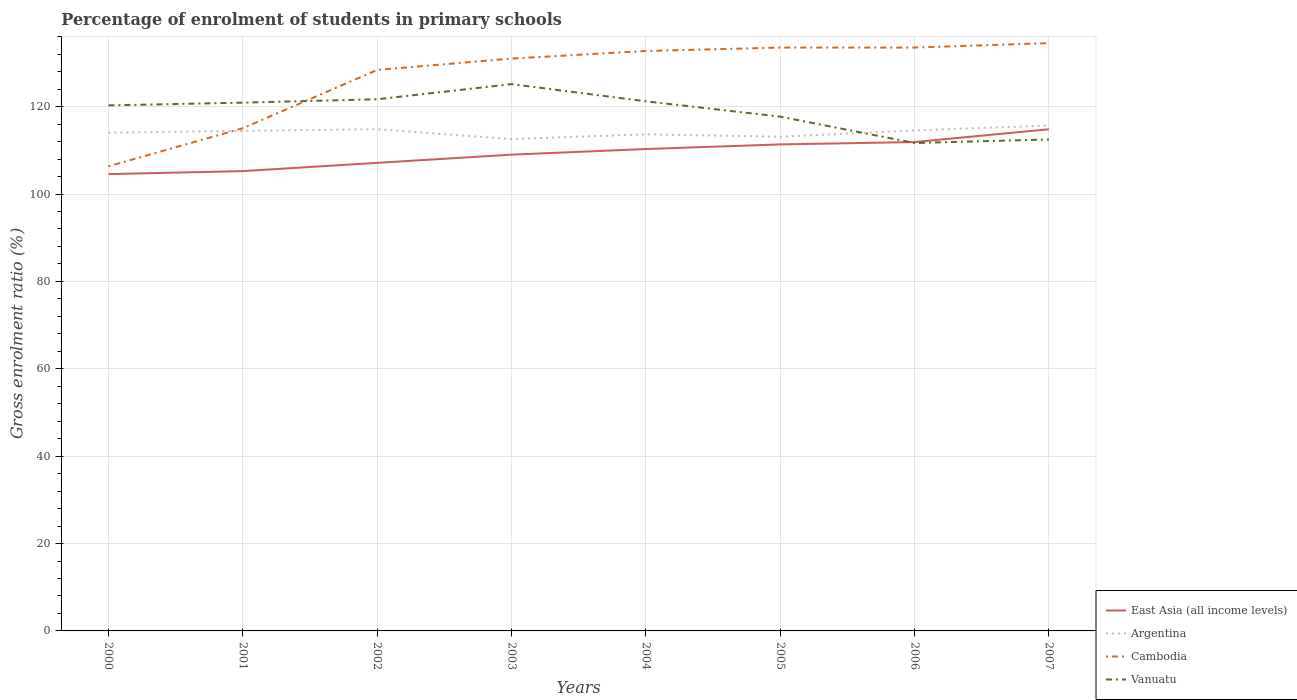Is the number of lines equal to the number of legend labels?
Your answer should be very brief. Yes. Across all years, what is the maximum percentage of students enrolled in primary schools in Cambodia?
Give a very brief answer. 106.34. In which year was the percentage of students enrolled in primary schools in Argentina maximum?
Your answer should be very brief. 2003. What is the total percentage of students enrolled in primary schools in Vanuatu in the graph?
Make the answer very short. 7.8. What is the difference between the highest and the second highest percentage of students enrolled in primary schools in Cambodia?
Offer a very short reply. 28.19. What is the difference between the highest and the lowest percentage of students enrolled in primary schools in East Asia (all income levels)?
Your response must be concise. 4. Is the percentage of students enrolled in primary schools in Argentina strictly greater than the percentage of students enrolled in primary schools in Cambodia over the years?
Your answer should be very brief. No. How many lines are there?
Give a very brief answer. 4. How many years are there in the graph?
Your answer should be very brief. 8. Does the graph contain any zero values?
Your response must be concise. No. Where does the legend appear in the graph?
Give a very brief answer. Bottom right. How many legend labels are there?
Your response must be concise. 4. How are the legend labels stacked?
Give a very brief answer. Vertical. What is the title of the graph?
Provide a short and direct response. Percentage of enrolment of students in primary schools. What is the label or title of the X-axis?
Keep it short and to the point. Years. What is the label or title of the Y-axis?
Provide a succinct answer. Gross enrolment ratio (%). What is the Gross enrolment ratio (%) in East Asia (all income levels) in 2000?
Offer a terse response. 104.55. What is the Gross enrolment ratio (%) in Argentina in 2000?
Keep it short and to the point. 114.03. What is the Gross enrolment ratio (%) of Cambodia in 2000?
Offer a terse response. 106.34. What is the Gross enrolment ratio (%) in Vanuatu in 2000?
Make the answer very short. 120.28. What is the Gross enrolment ratio (%) of East Asia (all income levels) in 2001?
Provide a succinct answer. 105.24. What is the Gross enrolment ratio (%) of Argentina in 2001?
Provide a short and direct response. 114.45. What is the Gross enrolment ratio (%) in Cambodia in 2001?
Make the answer very short. 115.05. What is the Gross enrolment ratio (%) of Vanuatu in 2001?
Offer a very short reply. 120.91. What is the Gross enrolment ratio (%) in East Asia (all income levels) in 2002?
Ensure brevity in your answer.  107.13. What is the Gross enrolment ratio (%) of Argentina in 2002?
Offer a terse response. 114.83. What is the Gross enrolment ratio (%) of Cambodia in 2002?
Your response must be concise. 128.4. What is the Gross enrolment ratio (%) in Vanuatu in 2002?
Ensure brevity in your answer.  121.68. What is the Gross enrolment ratio (%) of East Asia (all income levels) in 2003?
Offer a terse response. 109.01. What is the Gross enrolment ratio (%) in Argentina in 2003?
Offer a very short reply. 112.58. What is the Gross enrolment ratio (%) in Cambodia in 2003?
Give a very brief answer. 131. What is the Gross enrolment ratio (%) in Vanuatu in 2003?
Provide a short and direct response. 125.15. What is the Gross enrolment ratio (%) in East Asia (all income levels) in 2004?
Ensure brevity in your answer.  110.29. What is the Gross enrolment ratio (%) in Argentina in 2004?
Provide a succinct answer. 113.66. What is the Gross enrolment ratio (%) of Cambodia in 2004?
Ensure brevity in your answer.  132.73. What is the Gross enrolment ratio (%) in Vanuatu in 2004?
Offer a terse response. 121.22. What is the Gross enrolment ratio (%) of East Asia (all income levels) in 2005?
Your answer should be very brief. 111.35. What is the Gross enrolment ratio (%) in Argentina in 2005?
Provide a short and direct response. 113.11. What is the Gross enrolment ratio (%) of Cambodia in 2005?
Provide a short and direct response. 133.52. What is the Gross enrolment ratio (%) of Vanuatu in 2005?
Provide a short and direct response. 117.71. What is the Gross enrolment ratio (%) of East Asia (all income levels) in 2006?
Ensure brevity in your answer.  111.89. What is the Gross enrolment ratio (%) in Argentina in 2006?
Keep it short and to the point. 114.55. What is the Gross enrolment ratio (%) in Cambodia in 2006?
Offer a very short reply. 133.51. What is the Gross enrolment ratio (%) in Vanuatu in 2006?
Your answer should be compact. 111.67. What is the Gross enrolment ratio (%) in East Asia (all income levels) in 2007?
Provide a succinct answer. 114.82. What is the Gross enrolment ratio (%) in Argentina in 2007?
Make the answer very short. 115.67. What is the Gross enrolment ratio (%) in Cambodia in 2007?
Your answer should be compact. 134.53. What is the Gross enrolment ratio (%) in Vanuatu in 2007?
Give a very brief answer. 112.48. Across all years, what is the maximum Gross enrolment ratio (%) of East Asia (all income levels)?
Your answer should be very brief. 114.82. Across all years, what is the maximum Gross enrolment ratio (%) in Argentina?
Provide a short and direct response. 115.67. Across all years, what is the maximum Gross enrolment ratio (%) in Cambodia?
Your answer should be compact. 134.53. Across all years, what is the maximum Gross enrolment ratio (%) in Vanuatu?
Ensure brevity in your answer.  125.15. Across all years, what is the minimum Gross enrolment ratio (%) in East Asia (all income levels)?
Make the answer very short. 104.55. Across all years, what is the minimum Gross enrolment ratio (%) of Argentina?
Keep it short and to the point. 112.58. Across all years, what is the minimum Gross enrolment ratio (%) in Cambodia?
Your response must be concise. 106.34. Across all years, what is the minimum Gross enrolment ratio (%) in Vanuatu?
Ensure brevity in your answer.  111.67. What is the total Gross enrolment ratio (%) in East Asia (all income levels) in the graph?
Keep it short and to the point. 874.29. What is the total Gross enrolment ratio (%) of Argentina in the graph?
Ensure brevity in your answer.  912.89. What is the total Gross enrolment ratio (%) in Cambodia in the graph?
Keep it short and to the point. 1015.09. What is the total Gross enrolment ratio (%) in Vanuatu in the graph?
Ensure brevity in your answer.  951.1. What is the difference between the Gross enrolment ratio (%) of East Asia (all income levels) in 2000 and that in 2001?
Ensure brevity in your answer.  -0.69. What is the difference between the Gross enrolment ratio (%) of Argentina in 2000 and that in 2001?
Offer a terse response. -0.42. What is the difference between the Gross enrolment ratio (%) of Cambodia in 2000 and that in 2001?
Give a very brief answer. -8.71. What is the difference between the Gross enrolment ratio (%) of Vanuatu in 2000 and that in 2001?
Your answer should be very brief. -0.62. What is the difference between the Gross enrolment ratio (%) of East Asia (all income levels) in 2000 and that in 2002?
Make the answer very short. -2.57. What is the difference between the Gross enrolment ratio (%) of Argentina in 2000 and that in 2002?
Offer a very short reply. -0.8. What is the difference between the Gross enrolment ratio (%) in Cambodia in 2000 and that in 2002?
Your answer should be compact. -22.05. What is the difference between the Gross enrolment ratio (%) of Vanuatu in 2000 and that in 2002?
Your answer should be compact. -1.4. What is the difference between the Gross enrolment ratio (%) in East Asia (all income levels) in 2000 and that in 2003?
Ensure brevity in your answer.  -4.45. What is the difference between the Gross enrolment ratio (%) of Argentina in 2000 and that in 2003?
Give a very brief answer. 1.46. What is the difference between the Gross enrolment ratio (%) in Cambodia in 2000 and that in 2003?
Provide a short and direct response. -24.66. What is the difference between the Gross enrolment ratio (%) of Vanuatu in 2000 and that in 2003?
Offer a very short reply. -4.86. What is the difference between the Gross enrolment ratio (%) in East Asia (all income levels) in 2000 and that in 2004?
Provide a short and direct response. -5.74. What is the difference between the Gross enrolment ratio (%) in Argentina in 2000 and that in 2004?
Ensure brevity in your answer.  0.38. What is the difference between the Gross enrolment ratio (%) of Cambodia in 2000 and that in 2004?
Make the answer very short. -26.39. What is the difference between the Gross enrolment ratio (%) of Vanuatu in 2000 and that in 2004?
Provide a succinct answer. -0.93. What is the difference between the Gross enrolment ratio (%) in East Asia (all income levels) in 2000 and that in 2005?
Your response must be concise. -6.8. What is the difference between the Gross enrolment ratio (%) in Argentina in 2000 and that in 2005?
Your answer should be very brief. 0.92. What is the difference between the Gross enrolment ratio (%) of Cambodia in 2000 and that in 2005?
Your answer should be compact. -27.17. What is the difference between the Gross enrolment ratio (%) of Vanuatu in 2000 and that in 2005?
Your answer should be very brief. 2.58. What is the difference between the Gross enrolment ratio (%) of East Asia (all income levels) in 2000 and that in 2006?
Offer a terse response. -7.34. What is the difference between the Gross enrolment ratio (%) of Argentina in 2000 and that in 2006?
Give a very brief answer. -0.52. What is the difference between the Gross enrolment ratio (%) in Cambodia in 2000 and that in 2006?
Your answer should be compact. -27.17. What is the difference between the Gross enrolment ratio (%) in Vanuatu in 2000 and that in 2006?
Your response must be concise. 8.62. What is the difference between the Gross enrolment ratio (%) in East Asia (all income levels) in 2000 and that in 2007?
Make the answer very short. -10.26. What is the difference between the Gross enrolment ratio (%) in Argentina in 2000 and that in 2007?
Offer a very short reply. -1.64. What is the difference between the Gross enrolment ratio (%) in Cambodia in 2000 and that in 2007?
Provide a short and direct response. -28.19. What is the difference between the Gross enrolment ratio (%) of Vanuatu in 2000 and that in 2007?
Your answer should be very brief. 7.8. What is the difference between the Gross enrolment ratio (%) of East Asia (all income levels) in 2001 and that in 2002?
Provide a short and direct response. -1.89. What is the difference between the Gross enrolment ratio (%) in Argentina in 2001 and that in 2002?
Make the answer very short. -0.38. What is the difference between the Gross enrolment ratio (%) of Cambodia in 2001 and that in 2002?
Provide a succinct answer. -13.34. What is the difference between the Gross enrolment ratio (%) in Vanuatu in 2001 and that in 2002?
Your response must be concise. -0.77. What is the difference between the Gross enrolment ratio (%) in East Asia (all income levels) in 2001 and that in 2003?
Your answer should be compact. -3.77. What is the difference between the Gross enrolment ratio (%) of Argentina in 2001 and that in 2003?
Provide a short and direct response. 1.88. What is the difference between the Gross enrolment ratio (%) of Cambodia in 2001 and that in 2003?
Ensure brevity in your answer.  -15.95. What is the difference between the Gross enrolment ratio (%) in Vanuatu in 2001 and that in 2003?
Your answer should be very brief. -4.24. What is the difference between the Gross enrolment ratio (%) of East Asia (all income levels) in 2001 and that in 2004?
Keep it short and to the point. -5.05. What is the difference between the Gross enrolment ratio (%) in Argentina in 2001 and that in 2004?
Your answer should be compact. 0.79. What is the difference between the Gross enrolment ratio (%) of Cambodia in 2001 and that in 2004?
Give a very brief answer. -17.68. What is the difference between the Gross enrolment ratio (%) of Vanuatu in 2001 and that in 2004?
Your answer should be very brief. -0.31. What is the difference between the Gross enrolment ratio (%) in East Asia (all income levels) in 2001 and that in 2005?
Your answer should be very brief. -6.11. What is the difference between the Gross enrolment ratio (%) in Argentina in 2001 and that in 2005?
Your answer should be compact. 1.34. What is the difference between the Gross enrolment ratio (%) of Cambodia in 2001 and that in 2005?
Offer a terse response. -18.46. What is the difference between the Gross enrolment ratio (%) of Vanuatu in 2001 and that in 2005?
Give a very brief answer. 3.2. What is the difference between the Gross enrolment ratio (%) in East Asia (all income levels) in 2001 and that in 2006?
Give a very brief answer. -6.65. What is the difference between the Gross enrolment ratio (%) in Argentina in 2001 and that in 2006?
Provide a succinct answer. -0.1. What is the difference between the Gross enrolment ratio (%) of Cambodia in 2001 and that in 2006?
Offer a terse response. -18.46. What is the difference between the Gross enrolment ratio (%) of Vanuatu in 2001 and that in 2006?
Keep it short and to the point. 9.24. What is the difference between the Gross enrolment ratio (%) in East Asia (all income levels) in 2001 and that in 2007?
Provide a succinct answer. -9.58. What is the difference between the Gross enrolment ratio (%) of Argentina in 2001 and that in 2007?
Provide a succinct answer. -1.22. What is the difference between the Gross enrolment ratio (%) of Cambodia in 2001 and that in 2007?
Offer a terse response. -19.48. What is the difference between the Gross enrolment ratio (%) of Vanuatu in 2001 and that in 2007?
Keep it short and to the point. 8.43. What is the difference between the Gross enrolment ratio (%) of East Asia (all income levels) in 2002 and that in 2003?
Your answer should be compact. -1.88. What is the difference between the Gross enrolment ratio (%) of Argentina in 2002 and that in 2003?
Offer a very short reply. 2.26. What is the difference between the Gross enrolment ratio (%) in Cambodia in 2002 and that in 2003?
Ensure brevity in your answer.  -2.6. What is the difference between the Gross enrolment ratio (%) in Vanuatu in 2002 and that in 2003?
Give a very brief answer. -3.46. What is the difference between the Gross enrolment ratio (%) in East Asia (all income levels) in 2002 and that in 2004?
Provide a succinct answer. -3.16. What is the difference between the Gross enrolment ratio (%) of Argentina in 2002 and that in 2004?
Offer a terse response. 1.17. What is the difference between the Gross enrolment ratio (%) in Cambodia in 2002 and that in 2004?
Your answer should be compact. -4.33. What is the difference between the Gross enrolment ratio (%) in Vanuatu in 2002 and that in 2004?
Offer a very short reply. 0.47. What is the difference between the Gross enrolment ratio (%) of East Asia (all income levels) in 2002 and that in 2005?
Offer a terse response. -4.22. What is the difference between the Gross enrolment ratio (%) of Argentina in 2002 and that in 2005?
Give a very brief answer. 1.72. What is the difference between the Gross enrolment ratio (%) of Cambodia in 2002 and that in 2005?
Offer a terse response. -5.12. What is the difference between the Gross enrolment ratio (%) of Vanuatu in 2002 and that in 2005?
Provide a short and direct response. 3.98. What is the difference between the Gross enrolment ratio (%) of East Asia (all income levels) in 2002 and that in 2006?
Make the answer very short. -4.76. What is the difference between the Gross enrolment ratio (%) of Argentina in 2002 and that in 2006?
Provide a short and direct response. 0.28. What is the difference between the Gross enrolment ratio (%) in Cambodia in 2002 and that in 2006?
Your response must be concise. -5.12. What is the difference between the Gross enrolment ratio (%) in Vanuatu in 2002 and that in 2006?
Make the answer very short. 10.02. What is the difference between the Gross enrolment ratio (%) of East Asia (all income levels) in 2002 and that in 2007?
Make the answer very short. -7.69. What is the difference between the Gross enrolment ratio (%) of Argentina in 2002 and that in 2007?
Your answer should be compact. -0.84. What is the difference between the Gross enrolment ratio (%) in Cambodia in 2002 and that in 2007?
Offer a very short reply. -6.14. What is the difference between the Gross enrolment ratio (%) of Vanuatu in 2002 and that in 2007?
Ensure brevity in your answer.  9.2. What is the difference between the Gross enrolment ratio (%) in East Asia (all income levels) in 2003 and that in 2004?
Keep it short and to the point. -1.28. What is the difference between the Gross enrolment ratio (%) in Argentina in 2003 and that in 2004?
Make the answer very short. -1.08. What is the difference between the Gross enrolment ratio (%) in Cambodia in 2003 and that in 2004?
Your response must be concise. -1.73. What is the difference between the Gross enrolment ratio (%) in Vanuatu in 2003 and that in 2004?
Offer a terse response. 3.93. What is the difference between the Gross enrolment ratio (%) in East Asia (all income levels) in 2003 and that in 2005?
Keep it short and to the point. -2.34. What is the difference between the Gross enrolment ratio (%) of Argentina in 2003 and that in 2005?
Give a very brief answer. -0.53. What is the difference between the Gross enrolment ratio (%) in Cambodia in 2003 and that in 2005?
Provide a short and direct response. -2.52. What is the difference between the Gross enrolment ratio (%) in Vanuatu in 2003 and that in 2005?
Your response must be concise. 7.44. What is the difference between the Gross enrolment ratio (%) in East Asia (all income levels) in 2003 and that in 2006?
Offer a very short reply. -2.88. What is the difference between the Gross enrolment ratio (%) in Argentina in 2003 and that in 2006?
Offer a terse response. -1.98. What is the difference between the Gross enrolment ratio (%) of Cambodia in 2003 and that in 2006?
Keep it short and to the point. -2.51. What is the difference between the Gross enrolment ratio (%) in Vanuatu in 2003 and that in 2006?
Your answer should be very brief. 13.48. What is the difference between the Gross enrolment ratio (%) in East Asia (all income levels) in 2003 and that in 2007?
Ensure brevity in your answer.  -5.81. What is the difference between the Gross enrolment ratio (%) in Argentina in 2003 and that in 2007?
Offer a very short reply. -3.1. What is the difference between the Gross enrolment ratio (%) in Cambodia in 2003 and that in 2007?
Offer a terse response. -3.53. What is the difference between the Gross enrolment ratio (%) of Vanuatu in 2003 and that in 2007?
Give a very brief answer. 12.66. What is the difference between the Gross enrolment ratio (%) in East Asia (all income levels) in 2004 and that in 2005?
Give a very brief answer. -1.06. What is the difference between the Gross enrolment ratio (%) of Argentina in 2004 and that in 2005?
Provide a short and direct response. 0.55. What is the difference between the Gross enrolment ratio (%) of Cambodia in 2004 and that in 2005?
Ensure brevity in your answer.  -0.79. What is the difference between the Gross enrolment ratio (%) in Vanuatu in 2004 and that in 2005?
Your response must be concise. 3.51. What is the difference between the Gross enrolment ratio (%) in East Asia (all income levels) in 2004 and that in 2006?
Your answer should be very brief. -1.6. What is the difference between the Gross enrolment ratio (%) of Argentina in 2004 and that in 2006?
Offer a terse response. -0.9. What is the difference between the Gross enrolment ratio (%) in Cambodia in 2004 and that in 2006?
Offer a very short reply. -0.78. What is the difference between the Gross enrolment ratio (%) of Vanuatu in 2004 and that in 2006?
Provide a succinct answer. 9.55. What is the difference between the Gross enrolment ratio (%) of East Asia (all income levels) in 2004 and that in 2007?
Your answer should be compact. -4.53. What is the difference between the Gross enrolment ratio (%) of Argentina in 2004 and that in 2007?
Give a very brief answer. -2.02. What is the difference between the Gross enrolment ratio (%) of Cambodia in 2004 and that in 2007?
Your response must be concise. -1.8. What is the difference between the Gross enrolment ratio (%) of Vanuatu in 2004 and that in 2007?
Keep it short and to the point. 8.73. What is the difference between the Gross enrolment ratio (%) in East Asia (all income levels) in 2005 and that in 2006?
Your response must be concise. -0.54. What is the difference between the Gross enrolment ratio (%) of Argentina in 2005 and that in 2006?
Your answer should be very brief. -1.44. What is the difference between the Gross enrolment ratio (%) of Cambodia in 2005 and that in 2006?
Keep it short and to the point. 0. What is the difference between the Gross enrolment ratio (%) in Vanuatu in 2005 and that in 2006?
Your answer should be very brief. 6.04. What is the difference between the Gross enrolment ratio (%) in East Asia (all income levels) in 2005 and that in 2007?
Give a very brief answer. -3.47. What is the difference between the Gross enrolment ratio (%) of Argentina in 2005 and that in 2007?
Your answer should be very brief. -2.56. What is the difference between the Gross enrolment ratio (%) in Cambodia in 2005 and that in 2007?
Provide a succinct answer. -1.01. What is the difference between the Gross enrolment ratio (%) of Vanuatu in 2005 and that in 2007?
Ensure brevity in your answer.  5.22. What is the difference between the Gross enrolment ratio (%) in East Asia (all income levels) in 2006 and that in 2007?
Provide a succinct answer. -2.93. What is the difference between the Gross enrolment ratio (%) in Argentina in 2006 and that in 2007?
Offer a very short reply. -1.12. What is the difference between the Gross enrolment ratio (%) of Cambodia in 2006 and that in 2007?
Offer a very short reply. -1.02. What is the difference between the Gross enrolment ratio (%) in Vanuatu in 2006 and that in 2007?
Make the answer very short. -0.82. What is the difference between the Gross enrolment ratio (%) in East Asia (all income levels) in 2000 and the Gross enrolment ratio (%) in Argentina in 2001?
Make the answer very short. -9.9. What is the difference between the Gross enrolment ratio (%) in East Asia (all income levels) in 2000 and the Gross enrolment ratio (%) in Cambodia in 2001?
Offer a very short reply. -10.5. What is the difference between the Gross enrolment ratio (%) in East Asia (all income levels) in 2000 and the Gross enrolment ratio (%) in Vanuatu in 2001?
Make the answer very short. -16.35. What is the difference between the Gross enrolment ratio (%) of Argentina in 2000 and the Gross enrolment ratio (%) of Cambodia in 2001?
Give a very brief answer. -1.02. What is the difference between the Gross enrolment ratio (%) of Argentina in 2000 and the Gross enrolment ratio (%) of Vanuatu in 2001?
Make the answer very short. -6.88. What is the difference between the Gross enrolment ratio (%) in Cambodia in 2000 and the Gross enrolment ratio (%) in Vanuatu in 2001?
Your answer should be compact. -14.57. What is the difference between the Gross enrolment ratio (%) in East Asia (all income levels) in 2000 and the Gross enrolment ratio (%) in Argentina in 2002?
Your response must be concise. -10.28. What is the difference between the Gross enrolment ratio (%) in East Asia (all income levels) in 2000 and the Gross enrolment ratio (%) in Cambodia in 2002?
Your response must be concise. -23.84. What is the difference between the Gross enrolment ratio (%) of East Asia (all income levels) in 2000 and the Gross enrolment ratio (%) of Vanuatu in 2002?
Offer a terse response. -17.13. What is the difference between the Gross enrolment ratio (%) of Argentina in 2000 and the Gross enrolment ratio (%) of Cambodia in 2002?
Your response must be concise. -14.36. What is the difference between the Gross enrolment ratio (%) of Argentina in 2000 and the Gross enrolment ratio (%) of Vanuatu in 2002?
Offer a terse response. -7.65. What is the difference between the Gross enrolment ratio (%) in Cambodia in 2000 and the Gross enrolment ratio (%) in Vanuatu in 2002?
Keep it short and to the point. -15.34. What is the difference between the Gross enrolment ratio (%) of East Asia (all income levels) in 2000 and the Gross enrolment ratio (%) of Argentina in 2003?
Your answer should be very brief. -8.02. What is the difference between the Gross enrolment ratio (%) in East Asia (all income levels) in 2000 and the Gross enrolment ratio (%) in Cambodia in 2003?
Give a very brief answer. -26.45. What is the difference between the Gross enrolment ratio (%) in East Asia (all income levels) in 2000 and the Gross enrolment ratio (%) in Vanuatu in 2003?
Provide a succinct answer. -20.59. What is the difference between the Gross enrolment ratio (%) of Argentina in 2000 and the Gross enrolment ratio (%) of Cambodia in 2003?
Offer a terse response. -16.97. What is the difference between the Gross enrolment ratio (%) of Argentina in 2000 and the Gross enrolment ratio (%) of Vanuatu in 2003?
Offer a very short reply. -11.12. What is the difference between the Gross enrolment ratio (%) of Cambodia in 2000 and the Gross enrolment ratio (%) of Vanuatu in 2003?
Provide a short and direct response. -18.8. What is the difference between the Gross enrolment ratio (%) of East Asia (all income levels) in 2000 and the Gross enrolment ratio (%) of Argentina in 2004?
Provide a short and direct response. -9.1. What is the difference between the Gross enrolment ratio (%) in East Asia (all income levels) in 2000 and the Gross enrolment ratio (%) in Cambodia in 2004?
Your answer should be very brief. -28.17. What is the difference between the Gross enrolment ratio (%) of East Asia (all income levels) in 2000 and the Gross enrolment ratio (%) of Vanuatu in 2004?
Keep it short and to the point. -16.66. What is the difference between the Gross enrolment ratio (%) of Argentina in 2000 and the Gross enrolment ratio (%) of Cambodia in 2004?
Provide a short and direct response. -18.7. What is the difference between the Gross enrolment ratio (%) of Argentina in 2000 and the Gross enrolment ratio (%) of Vanuatu in 2004?
Ensure brevity in your answer.  -7.18. What is the difference between the Gross enrolment ratio (%) of Cambodia in 2000 and the Gross enrolment ratio (%) of Vanuatu in 2004?
Give a very brief answer. -14.87. What is the difference between the Gross enrolment ratio (%) of East Asia (all income levels) in 2000 and the Gross enrolment ratio (%) of Argentina in 2005?
Provide a short and direct response. -8.56. What is the difference between the Gross enrolment ratio (%) of East Asia (all income levels) in 2000 and the Gross enrolment ratio (%) of Cambodia in 2005?
Ensure brevity in your answer.  -28.96. What is the difference between the Gross enrolment ratio (%) in East Asia (all income levels) in 2000 and the Gross enrolment ratio (%) in Vanuatu in 2005?
Provide a short and direct response. -13.15. What is the difference between the Gross enrolment ratio (%) in Argentina in 2000 and the Gross enrolment ratio (%) in Cambodia in 2005?
Give a very brief answer. -19.49. What is the difference between the Gross enrolment ratio (%) of Argentina in 2000 and the Gross enrolment ratio (%) of Vanuatu in 2005?
Your response must be concise. -3.67. What is the difference between the Gross enrolment ratio (%) in Cambodia in 2000 and the Gross enrolment ratio (%) in Vanuatu in 2005?
Ensure brevity in your answer.  -11.36. What is the difference between the Gross enrolment ratio (%) of East Asia (all income levels) in 2000 and the Gross enrolment ratio (%) of Argentina in 2006?
Provide a short and direct response. -10. What is the difference between the Gross enrolment ratio (%) of East Asia (all income levels) in 2000 and the Gross enrolment ratio (%) of Cambodia in 2006?
Your response must be concise. -28.96. What is the difference between the Gross enrolment ratio (%) in East Asia (all income levels) in 2000 and the Gross enrolment ratio (%) in Vanuatu in 2006?
Give a very brief answer. -7.11. What is the difference between the Gross enrolment ratio (%) of Argentina in 2000 and the Gross enrolment ratio (%) of Cambodia in 2006?
Provide a short and direct response. -19.48. What is the difference between the Gross enrolment ratio (%) in Argentina in 2000 and the Gross enrolment ratio (%) in Vanuatu in 2006?
Offer a terse response. 2.37. What is the difference between the Gross enrolment ratio (%) of Cambodia in 2000 and the Gross enrolment ratio (%) of Vanuatu in 2006?
Your answer should be compact. -5.32. What is the difference between the Gross enrolment ratio (%) in East Asia (all income levels) in 2000 and the Gross enrolment ratio (%) in Argentina in 2007?
Your response must be concise. -11.12. What is the difference between the Gross enrolment ratio (%) of East Asia (all income levels) in 2000 and the Gross enrolment ratio (%) of Cambodia in 2007?
Offer a very short reply. -29.98. What is the difference between the Gross enrolment ratio (%) in East Asia (all income levels) in 2000 and the Gross enrolment ratio (%) in Vanuatu in 2007?
Provide a succinct answer. -7.93. What is the difference between the Gross enrolment ratio (%) in Argentina in 2000 and the Gross enrolment ratio (%) in Cambodia in 2007?
Ensure brevity in your answer.  -20.5. What is the difference between the Gross enrolment ratio (%) of Argentina in 2000 and the Gross enrolment ratio (%) of Vanuatu in 2007?
Your response must be concise. 1.55. What is the difference between the Gross enrolment ratio (%) of Cambodia in 2000 and the Gross enrolment ratio (%) of Vanuatu in 2007?
Your response must be concise. -6.14. What is the difference between the Gross enrolment ratio (%) of East Asia (all income levels) in 2001 and the Gross enrolment ratio (%) of Argentina in 2002?
Your response must be concise. -9.59. What is the difference between the Gross enrolment ratio (%) of East Asia (all income levels) in 2001 and the Gross enrolment ratio (%) of Cambodia in 2002?
Make the answer very short. -23.16. What is the difference between the Gross enrolment ratio (%) in East Asia (all income levels) in 2001 and the Gross enrolment ratio (%) in Vanuatu in 2002?
Provide a short and direct response. -16.44. What is the difference between the Gross enrolment ratio (%) in Argentina in 2001 and the Gross enrolment ratio (%) in Cambodia in 2002?
Your answer should be very brief. -13.94. What is the difference between the Gross enrolment ratio (%) in Argentina in 2001 and the Gross enrolment ratio (%) in Vanuatu in 2002?
Keep it short and to the point. -7.23. What is the difference between the Gross enrolment ratio (%) in Cambodia in 2001 and the Gross enrolment ratio (%) in Vanuatu in 2002?
Your answer should be very brief. -6.63. What is the difference between the Gross enrolment ratio (%) in East Asia (all income levels) in 2001 and the Gross enrolment ratio (%) in Argentina in 2003?
Your answer should be very brief. -7.34. What is the difference between the Gross enrolment ratio (%) in East Asia (all income levels) in 2001 and the Gross enrolment ratio (%) in Cambodia in 2003?
Your response must be concise. -25.76. What is the difference between the Gross enrolment ratio (%) of East Asia (all income levels) in 2001 and the Gross enrolment ratio (%) of Vanuatu in 2003?
Provide a succinct answer. -19.91. What is the difference between the Gross enrolment ratio (%) in Argentina in 2001 and the Gross enrolment ratio (%) in Cambodia in 2003?
Provide a succinct answer. -16.55. What is the difference between the Gross enrolment ratio (%) of Argentina in 2001 and the Gross enrolment ratio (%) of Vanuatu in 2003?
Provide a short and direct response. -10.7. What is the difference between the Gross enrolment ratio (%) of Cambodia in 2001 and the Gross enrolment ratio (%) of Vanuatu in 2003?
Provide a succinct answer. -10.09. What is the difference between the Gross enrolment ratio (%) of East Asia (all income levels) in 2001 and the Gross enrolment ratio (%) of Argentina in 2004?
Ensure brevity in your answer.  -8.42. What is the difference between the Gross enrolment ratio (%) of East Asia (all income levels) in 2001 and the Gross enrolment ratio (%) of Cambodia in 2004?
Your answer should be very brief. -27.49. What is the difference between the Gross enrolment ratio (%) in East Asia (all income levels) in 2001 and the Gross enrolment ratio (%) in Vanuatu in 2004?
Your answer should be very brief. -15.98. What is the difference between the Gross enrolment ratio (%) of Argentina in 2001 and the Gross enrolment ratio (%) of Cambodia in 2004?
Ensure brevity in your answer.  -18.28. What is the difference between the Gross enrolment ratio (%) in Argentina in 2001 and the Gross enrolment ratio (%) in Vanuatu in 2004?
Offer a very short reply. -6.76. What is the difference between the Gross enrolment ratio (%) of Cambodia in 2001 and the Gross enrolment ratio (%) of Vanuatu in 2004?
Provide a succinct answer. -6.16. What is the difference between the Gross enrolment ratio (%) in East Asia (all income levels) in 2001 and the Gross enrolment ratio (%) in Argentina in 2005?
Provide a succinct answer. -7.87. What is the difference between the Gross enrolment ratio (%) in East Asia (all income levels) in 2001 and the Gross enrolment ratio (%) in Cambodia in 2005?
Make the answer very short. -28.28. What is the difference between the Gross enrolment ratio (%) in East Asia (all income levels) in 2001 and the Gross enrolment ratio (%) in Vanuatu in 2005?
Ensure brevity in your answer.  -12.47. What is the difference between the Gross enrolment ratio (%) in Argentina in 2001 and the Gross enrolment ratio (%) in Cambodia in 2005?
Your response must be concise. -19.07. What is the difference between the Gross enrolment ratio (%) in Argentina in 2001 and the Gross enrolment ratio (%) in Vanuatu in 2005?
Provide a short and direct response. -3.25. What is the difference between the Gross enrolment ratio (%) in Cambodia in 2001 and the Gross enrolment ratio (%) in Vanuatu in 2005?
Your answer should be compact. -2.65. What is the difference between the Gross enrolment ratio (%) in East Asia (all income levels) in 2001 and the Gross enrolment ratio (%) in Argentina in 2006?
Give a very brief answer. -9.31. What is the difference between the Gross enrolment ratio (%) in East Asia (all income levels) in 2001 and the Gross enrolment ratio (%) in Cambodia in 2006?
Ensure brevity in your answer.  -28.27. What is the difference between the Gross enrolment ratio (%) of East Asia (all income levels) in 2001 and the Gross enrolment ratio (%) of Vanuatu in 2006?
Ensure brevity in your answer.  -6.43. What is the difference between the Gross enrolment ratio (%) in Argentina in 2001 and the Gross enrolment ratio (%) in Cambodia in 2006?
Give a very brief answer. -19.06. What is the difference between the Gross enrolment ratio (%) of Argentina in 2001 and the Gross enrolment ratio (%) of Vanuatu in 2006?
Keep it short and to the point. 2.79. What is the difference between the Gross enrolment ratio (%) of Cambodia in 2001 and the Gross enrolment ratio (%) of Vanuatu in 2006?
Make the answer very short. 3.39. What is the difference between the Gross enrolment ratio (%) in East Asia (all income levels) in 2001 and the Gross enrolment ratio (%) in Argentina in 2007?
Give a very brief answer. -10.43. What is the difference between the Gross enrolment ratio (%) of East Asia (all income levels) in 2001 and the Gross enrolment ratio (%) of Cambodia in 2007?
Offer a very short reply. -29.29. What is the difference between the Gross enrolment ratio (%) of East Asia (all income levels) in 2001 and the Gross enrolment ratio (%) of Vanuatu in 2007?
Your answer should be compact. -7.24. What is the difference between the Gross enrolment ratio (%) in Argentina in 2001 and the Gross enrolment ratio (%) in Cambodia in 2007?
Offer a very short reply. -20.08. What is the difference between the Gross enrolment ratio (%) in Argentina in 2001 and the Gross enrolment ratio (%) in Vanuatu in 2007?
Offer a terse response. 1.97. What is the difference between the Gross enrolment ratio (%) in Cambodia in 2001 and the Gross enrolment ratio (%) in Vanuatu in 2007?
Ensure brevity in your answer.  2.57. What is the difference between the Gross enrolment ratio (%) of East Asia (all income levels) in 2002 and the Gross enrolment ratio (%) of Argentina in 2003?
Give a very brief answer. -5.45. What is the difference between the Gross enrolment ratio (%) in East Asia (all income levels) in 2002 and the Gross enrolment ratio (%) in Cambodia in 2003?
Provide a succinct answer. -23.87. What is the difference between the Gross enrolment ratio (%) of East Asia (all income levels) in 2002 and the Gross enrolment ratio (%) of Vanuatu in 2003?
Offer a very short reply. -18.02. What is the difference between the Gross enrolment ratio (%) of Argentina in 2002 and the Gross enrolment ratio (%) of Cambodia in 2003?
Offer a very short reply. -16.17. What is the difference between the Gross enrolment ratio (%) in Argentina in 2002 and the Gross enrolment ratio (%) in Vanuatu in 2003?
Keep it short and to the point. -10.32. What is the difference between the Gross enrolment ratio (%) in Cambodia in 2002 and the Gross enrolment ratio (%) in Vanuatu in 2003?
Offer a terse response. 3.25. What is the difference between the Gross enrolment ratio (%) of East Asia (all income levels) in 2002 and the Gross enrolment ratio (%) of Argentina in 2004?
Ensure brevity in your answer.  -6.53. What is the difference between the Gross enrolment ratio (%) in East Asia (all income levels) in 2002 and the Gross enrolment ratio (%) in Cambodia in 2004?
Offer a very short reply. -25.6. What is the difference between the Gross enrolment ratio (%) in East Asia (all income levels) in 2002 and the Gross enrolment ratio (%) in Vanuatu in 2004?
Your response must be concise. -14.09. What is the difference between the Gross enrolment ratio (%) in Argentina in 2002 and the Gross enrolment ratio (%) in Cambodia in 2004?
Offer a terse response. -17.9. What is the difference between the Gross enrolment ratio (%) in Argentina in 2002 and the Gross enrolment ratio (%) in Vanuatu in 2004?
Your response must be concise. -6.38. What is the difference between the Gross enrolment ratio (%) in Cambodia in 2002 and the Gross enrolment ratio (%) in Vanuatu in 2004?
Provide a short and direct response. 7.18. What is the difference between the Gross enrolment ratio (%) of East Asia (all income levels) in 2002 and the Gross enrolment ratio (%) of Argentina in 2005?
Provide a short and direct response. -5.98. What is the difference between the Gross enrolment ratio (%) of East Asia (all income levels) in 2002 and the Gross enrolment ratio (%) of Cambodia in 2005?
Your answer should be compact. -26.39. What is the difference between the Gross enrolment ratio (%) of East Asia (all income levels) in 2002 and the Gross enrolment ratio (%) of Vanuatu in 2005?
Provide a succinct answer. -10.58. What is the difference between the Gross enrolment ratio (%) of Argentina in 2002 and the Gross enrolment ratio (%) of Cambodia in 2005?
Make the answer very short. -18.69. What is the difference between the Gross enrolment ratio (%) in Argentina in 2002 and the Gross enrolment ratio (%) in Vanuatu in 2005?
Make the answer very short. -2.87. What is the difference between the Gross enrolment ratio (%) in Cambodia in 2002 and the Gross enrolment ratio (%) in Vanuatu in 2005?
Your answer should be very brief. 10.69. What is the difference between the Gross enrolment ratio (%) in East Asia (all income levels) in 2002 and the Gross enrolment ratio (%) in Argentina in 2006?
Give a very brief answer. -7.42. What is the difference between the Gross enrolment ratio (%) in East Asia (all income levels) in 2002 and the Gross enrolment ratio (%) in Cambodia in 2006?
Offer a very short reply. -26.38. What is the difference between the Gross enrolment ratio (%) in East Asia (all income levels) in 2002 and the Gross enrolment ratio (%) in Vanuatu in 2006?
Offer a terse response. -4.54. What is the difference between the Gross enrolment ratio (%) in Argentina in 2002 and the Gross enrolment ratio (%) in Cambodia in 2006?
Ensure brevity in your answer.  -18.68. What is the difference between the Gross enrolment ratio (%) of Argentina in 2002 and the Gross enrolment ratio (%) of Vanuatu in 2006?
Offer a terse response. 3.17. What is the difference between the Gross enrolment ratio (%) of Cambodia in 2002 and the Gross enrolment ratio (%) of Vanuatu in 2006?
Make the answer very short. 16.73. What is the difference between the Gross enrolment ratio (%) in East Asia (all income levels) in 2002 and the Gross enrolment ratio (%) in Argentina in 2007?
Offer a very short reply. -8.54. What is the difference between the Gross enrolment ratio (%) of East Asia (all income levels) in 2002 and the Gross enrolment ratio (%) of Cambodia in 2007?
Ensure brevity in your answer.  -27.4. What is the difference between the Gross enrolment ratio (%) of East Asia (all income levels) in 2002 and the Gross enrolment ratio (%) of Vanuatu in 2007?
Ensure brevity in your answer.  -5.35. What is the difference between the Gross enrolment ratio (%) in Argentina in 2002 and the Gross enrolment ratio (%) in Cambodia in 2007?
Make the answer very short. -19.7. What is the difference between the Gross enrolment ratio (%) in Argentina in 2002 and the Gross enrolment ratio (%) in Vanuatu in 2007?
Provide a succinct answer. 2.35. What is the difference between the Gross enrolment ratio (%) of Cambodia in 2002 and the Gross enrolment ratio (%) of Vanuatu in 2007?
Offer a very short reply. 15.91. What is the difference between the Gross enrolment ratio (%) in East Asia (all income levels) in 2003 and the Gross enrolment ratio (%) in Argentina in 2004?
Provide a short and direct response. -4.65. What is the difference between the Gross enrolment ratio (%) of East Asia (all income levels) in 2003 and the Gross enrolment ratio (%) of Cambodia in 2004?
Make the answer very short. -23.72. What is the difference between the Gross enrolment ratio (%) of East Asia (all income levels) in 2003 and the Gross enrolment ratio (%) of Vanuatu in 2004?
Ensure brevity in your answer.  -12.21. What is the difference between the Gross enrolment ratio (%) in Argentina in 2003 and the Gross enrolment ratio (%) in Cambodia in 2004?
Your response must be concise. -20.15. What is the difference between the Gross enrolment ratio (%) in Argentina in 2003 and the Gross enrolment ratio (%) in Vanuatu in 2004?
Ensure brevity in your answer.  -8.64. What is the difference between the Gross enrolment ratio (%) in Cambodia in 2003 and the Gross enrolment ratio (%) in Vanuatu in 2004?
Offer a terse response. 9.79. What is the difference between the Gross enrolment ratio (%) of East Asia (all income levels) in 2003 and the Gross enrolment ratio (%) of Argentina in 2005?
Give a very brief answer. -4.1. What is the difference between the Gross enrolment ratio (%) of East Asia (all income levels) in 2003 and the Gross enrolment ratio (%) of Cambodia in 2005?
Make the answer very short. -24.51. What is the difference between the Gross enrolment ratio (%) in East Asia (all income levels) in 2003 and the Gross enrolment ratio (%) in Vanuatu in 2005?
Offer a very short reply. -8.7. What is the difference between the Gross enrolment ratio (%) of Argentina in 2003 and the Gross enrolment ratio (%) of Cambodia in 2005?
Offer a terse response. -20.94. What is the difference between the Gross enrolment ratio (%) in Argentina in 2003 and the Gross enrolment ratio (%) in Vanuatu in 2005?
Offer a very short reply. -5.13. What is the difference between the Gross enrolment ratio (%) in Cambodia in 2003 and the Gross enrolment ratio (%) in Vanuatu in 2005?
Provide a short and direct response. 13.3. What is the difference between the Gross enrolment ratio (%) in East Asia (all income levels) in 2003 and the Gross enrolment ratio (%) in Argentina in 2006?
Provide a short and direct response. -5.55. What is the difference between the Gross enrolment ratio (%) of East Asia (all income levels) in 2003 and the Gross enrolment ratio (%) of Cambodia in 2006?
Your response must be concise. -24.51. What is the difference between the Gross enrolment ratio (%) of East Asia (all income levels) in 2003 and the Gross enrolment ratio (%) of Vanuatu in 2006?
Ensure brevity in your answer.  -2.66. What is the difference between the Gross enrolment ratio (%) of Argentina in 2003 and the Gross enrolment ratio (%) of Cambodia in 2006?
Ensure brevity in your answer.  -20.94. What is the difference between the Gross enrolment ratio (%) of Argentina in 2003 and the Gross enrolment ratio (%) of Vanuatu in 2006?
Your answer should be compact. 0.91. What is the difference between the Gross enrolment ratio (%) in Cambodia in 2003 and the Gross enrolment ratio (%) in Vanuatu in 2006?
Make the answer very short. 19.33. What is the difference between the Gross enrolment ratio (%) in East Asia (all income levels) in 2003 and the Gross enrolment ratio (%) in Argentina in 2007?
Provide a succinct answer. -6.66. What is the difference between the Gross enrolment ratio (%) in East Asia (all income levels) in 2003 and the Gross enrolment ratio (%) in Cambodia in 2007?
Offer a very short reply. -25.52. What is the difference between the Gross enrolment ratio (%) in East Asia (all income levels) in 2003 and the Gross enrolment ratio (%) in Vanuatu in 2007?
Your answer should be compact. -3.47. What is the difference between the Gross enrolment ratio (%) in Argentina in 2003 and the Gross enrolment ratio (%) in Cambodia in 2007?
Provide a succinct answer. -21.96. What is the difference between the Gross enrolment ratio (%) of Argentina in 2003 and the Gross enrolment ratio (%) of Vanuatu in 2007?
Offer a very short reply. 0.09. What is the difference between the Gross enrolment ratio (%) in Cambodia in 2003 and the Gross enrolment ratio (%) in Vanuatu in 2007?
Your response must be concise. 18.52. What is the difference between the Gross enrolment ratio (%) in East Asia (all income levels) in 2004 and the Gross enrolment ratio (%) in Argentina in 2005?
Ensure brevity in your answer.  -2.82. What is the difference between the Gross enrolment ratio (%) in East Asia (all income levels) in 2004 and the Gross enrolment ratio (%) in Cambodia in 2005?
Your response must be concise. -23.23. What is the difference between the Gross enrolment ratio (%) in East Asia (all income levels) in 2004 and the Gross enrolment ratio (%) in Vanuatu in 2005?
Make the answer very short. -7.41. What is the difference between the Gross enrolment ratio (%) in Argentina in 2004 and the Gross enrolment ratio (%) in Cambodia in 2005?
Give a very brief answer. -19.86. What is the difference between the Gross enrolment ratio (%) of Argentina in 2004 and the Gross enrolment ratio (%) of Vanuatu in 2005?
Give a very brief answer. -4.05. What is the difference between the Gross enrolment ratio (%) of Cambodia in 2004 and the Gross enrolment ratio (%) of Vanuatu in 2005?
Your answer should be very brief. 15.02. What is the difference between the Gross enrolment ratio (%) of East Asia (all income levels) in 2004 and the Gross enrolment ratio (%) of Argentina in 2006?
Provide a succinct answer. -4.26. What is the difference between the Gross enrolment ratio (%) of East Asia (all income levels) in 2004 and the Gross enrolment ratio (%) of Cambodia in 2006?
Provide a short and direct response. -23.22. What is the difference between the Gross enrolment ratio (%) in East Asia (all income levels) in 2004 and the Gross enrolment ratio (%) in Vanuatu in 2006?
Provide a succinct answer. -1.38. What is the difference between the Gross enrolment ratio (%) in Argentina in 2004 and the Gross enrolment ratio (%) in Cambodia in 2006?
Your answer should be compact. -19.86. What is the difference between the Gross enrolment ratio (%) in Argentina in 2004 and the Gross enrolment ratio (%) in Vanuatu in 2006?
Offer a terse response. 1.99. What is the difference between the Gross enrolment ratio (%) of Cambodia in 2004 and the Gross enrolment ratio (%) of Vanuatu in 2006?
Offer a terse response. 21.06. What is the difference between the Gross enrolment ratio (%) in East Asia (all income levels) in 2004 and the Gross enrolment ratio (%) in Argentina in 2007?
Give a very brief answer. -5.38. What is the difference between the Gross enrolment ratio (%) in East Asia (all income levels) in 2004 and the Gross enrolment ratio (%) in Cambodia in 2007?
Offer a very short reply. -24.24. What is the difference between the Gross enrolment ratio (%) in East Asia (all income levels) in 2004 and the Gross enrolment ratio (%) in Vanuatu in 2007?
Your answer should be compact. -2.19. What is the difference between the Gross enrolment ratio (%) of Argentina in 2004 and the Gross enrolment ratio (%) of Cambodia in 2007?
Offer a very short reply. -20.88. What is the difference between the Gross enrolment ratio (%) in Argentina in 2004 and the Gross enrolment ratio (%) in Vanuatu in 2007?
Provide a succinct answer. 1.17. What is the difference between the Gross enrolment ratio (%) of Cambodia in 2004 and the Gross enrolment ratio (%) of Vanuatu in 2007?
Offer a very short reply. 20.25. What is the difference between the Gross enrolment ratio (%) of East Asia (all income levels) in 2005 and the Gross enrolment ratio (%) of Argentina in 2006?
Keep it short and to the point. -3.2. What is the difference between the Gross enrolment ratio (%) of East Asia (all income levels) in 2005 and the Gross enrolment ratio (%) of Cambodia in 2006?
Ensure brevity in your answer.  -22.16. What is the difference between the Gross enrolment ratio (%) of East Asia (all income levels) in 2005 and the Gross enrolment ratio (%) of Vanuatu in 2006?
Your answer should be compact. -0.32. What is the difference between the Gross enrolment ratio (%) of Argentina in 2005 and the Gross enrolment ratio (%) of Cambodia in 2006?
Your answer should be very brief. -20.4. What is the difference between the Gross enrolment ratio (%) of Argentina in 2005 and the Gross enrolment ratio (%) of Vanuatu in 2006?
Offer a terse response. 1.44. What is the difference between the Gross enrolment ratio (%) of Cambodia in 2005 and the Gross enrolment ratio (%) of Vanuatu in 2006?
Keep it short and to the point. 21.85. What is the difference between the Gross enrolment ratio (%) in East Asia (all income levels) in 2005 and the Gross enrolment ratio (%) in Argentina in 2007?
Ensure brevity in your answer.  -4.32. What is the difference between the Gross enrolment ratio (%) of East Asia (all income levels) in 2005 and the Gross enrolment ratio (%) of Cambodia in 2007?
Offer a terse response. -23.18. What is the difference between the Gross enrolment ratio (%) in East Asia (all income levels) in 2005 and the Gross enrolment ratio (%) in Vanuatu in 2007?
Offer a very short reply. -1.13. What is the difference between the Gross enrolment ratio (%) of Argentina in 2005 and the Gross enrolment ratio (%) of Cambodia in 2007?
Your response must be concise. -21.42. What is the difference between the Gross enrolment ratio (%) in Argentina in 2005 and the Gross enrolment ratio (%) in Vanuatu in 2007?
Provide a short and direct response. 0.63. What is the difference between the Gross enrolment ratio (%) of Cambodia in 2005 and the Gross enrolment ratio (%) of Vanuatu in 2007?
Offer a terse response. 21.03. What is the difference between the Gross enrolment ratio (%) in East Asia (all income levels) in 2006 and the Gross enrolment ratio (%) in Argentina in 2007?
Keep it short and to the point. -3.78. What is the difference between the Gross enrolment ratio (%) of East Asia (all income levels) in 2006 and the Gross enrolment ratio (%) of Cambodia in 2007?
Keep it short and to the point. -22.64. What is the difference between the Gross enrolment ratio (%) in East Asia (all income levels) in 2006 and the Gross enrolment ratio (%) in Vanuatu in 2007?
Keep it short and to the point. -0.59. What is the difference between the Gross enrolment ratio (%) of Argentina in 2006 and the Gross enrolment ratio (%) of Cambodia in 2007?
Offer a terse response. -19.98. What is the difference between the Gross enrolment ratio (%) in Argentina in 2006 and the Gross enrolment ratio (%) in Vanuatu in 2007?
Your answer should be compact. 2.07. What is the difference between the Gross enrolment ratio (%) in Cambodia in 2006 and the Gross enrolment ratio (%) in Vanuatu in 2007?
Make the answer very short. 21.03. What is the average Gross enrolment ratio (%) of East Asia (all income levels) per year?
Your answer should be very brief. 109.29. What is the average Gross enrolment ratio (%) in Argentina per year?
Keep it short and to the point. 114.11. What is the average Gross enrolment ratio (%) of Cambodia per year?
Provide a short and direct response. 126.89. What is the average Gross enrolment ratio (%) in Vanuatu per year?
Keep it short and to the point. 118.89. In the year 2000, what is the difference between the Gross enrolment ratio (%) in East Asia (all income levels) and Gross enrolment ratio (%) in Argentina?
Give a very brief answer. -9.48. In the year 2000, what is the difference between the Gross enrolment ratio (%) in East Asia (all income levels) and Gross enrolment ratio (%) in Cambodia?
Offer a terse response. -1.79. In the year 2000, what is the difference between the Gross enrolment ratio (%) in East Asia (all income levels) and Gross enrolment ratio (%) in Vanuatu?
Your response must be concise. -15.73. In the year 2000, what is the difference between the Gross enrolment ratio (%) of Argentina and Gross enrolment ratio (%) of Cambodia?
Offer a terse response. 7.69. In the year 2000, what is the difference between the Gross enrolment ratio (%) of Argentina and Gross enrolment ratio (%) of Vanuatu?
Offer a very short reply. -6.25. In the year 2000, what is the difference between the Gross enrolment ratio (%) of Cambodia and Gross enrolment ratio (%) of Vanuatu?
Your answer should be very brief. -13.94. In the year 2001, what is the difference between the Gross enrolment ratio (%) in East Asia (all income levels) and Gross enrolment ratio (%) in Argentina?
Your response must be concise. -9.21. In the year 2001, what is the difference between the Gross enrolment ratio (%) of East Asia (all income levels) and Gross enrolment ratio (%) of Cambodia?
Give a very brief answer. -9.81. In the year 2001, what is the difference between the Gross enrolment ratio (%) of East Asia (all income levels) and Gross enrolment ratio (%) of Vanuatu?
Provide a short and direct response. -15.67. In the year 2001, what is the difference between the Gross enrolment ratio (%) of Argentina and Gross enrolment ratio (%) of Cambodia?
Your answer should be compact. -0.6. In the year 2001, what is the difference between the Gross enrolment ratio (%) of Argentina and Gross enrolment ratio (%) of Vanuatu?
Your answer should be very brief. -6.46. In the year 2001, what is the difference between the Gross enrolment ratio (%) in Cambodia and Gross enrolment ratio (%) in Vanuatu?
Offer a very short reply. -5.86. In the year 2002, what is the difference between the Gross enrolment ratio (%) in East Asia (all income levels) and Gross enrolment ratio (%) in Argentina?
Your answer should be very brief. -7.7. In the year 2002, what is the difference between the Gross enrolment ratio (%) of East Asia (all income levels) and Gross enrolment ratio (%) of Cambodia?
Your answer should be compact. -21.27. In the year 2002, what is the difference between the Gross enrolment ratio (%) of East Asia (all income levels) and Gross enrolment ratio (%) of Vanuatu?
Give a very brief answer. -14.55. In the year 2002, what is the difference between the Gross enrolment ratio (%) in Argentina and Gross enrolment ratio (%) in Cambodia?
Keep it short and to the point. -13.56. In the year 2002, what is the difference between the Gross enrolment ratio (%) of Argentina and Gross enrolment ratio (%) of Vanuatu?
Keep it short and to the point. -6.85. In the year 2002, what is the difference between the Gross enrolment ratio (%) in Cambodia and Gross enrolment ratio (%) in Vanuatu?
Your answer should be compact. 6.71. In the year 2003, what is the difference between the Gross enrolment ratio (%) of East Asia (all income levels) and Gross enrolment ratio (%) of Argentina?
Keep it short and to the point. -3.57. In the year 2003, what is the difference between the Gross enrolment ratio (%) in East Asia (all income levels) and Gross enrolment ratio (%) in Cambodia?
Make the answer very short. -21.99. In the year 2003, what is the difference between the Gross enrolment ratio (%) of East Asia (all income levels) and Gross enrolment ratio (%) of Vanuatu?
Your answer should be compact. -16.14. In the year 2003, what is the difference between the Gross enrolment ratio (%) of Argentina and Gross enrolment ratio (%) of Cambodia?
Provide a succinct answer. -18.42. In the year 2003, what is the difference between the Gross enrolment ratio (%) of Argentina and Gross enrolment ratio (%) of Vanuatu?
Provide a short and direct response. -12.57. In the year 2003, what is the difference between the Gross enrolment ratio (%) of Cambodia and Gross enrolment ratio (%) of Vanuatu?
Your answer should be compact. 5.85. In the year 2004, what is the difference between the Gross enrolment ratio (%) in East Asia (all income levels) and Gross enrolment ratio (%) in Argentina?
Offer a very short reply. -3.37. In the year 2004, what is the difference between the Gross enrolment ratio (%) in East Asia (all income levels) and Gross enrolment ratio (%) in Cambodia?
Your response must be concise. -22.44. In the year 2004, what is the difference between the Gross enrolment ratio (%) of East Asia (all income levels) and Gross enrolment ratio (%) of Vanuatu?
Your answer should be very brief. -10.92. In the year 2004, what is the difference between the Gross enrolment ratio (%) in Argentina and Gross enrolment ratio (%) in Cambodia?
Your answer should be compact. -19.07. In the year 2004, what is the difference between the Gross enrolment ratio (%) in Argentina and Gross enrolment ratio (%) in Vanuatu?
Give a very brief answer. -7.56. In the year 2004, what is the difference between the Gross enrolment ratio (%) of Cambodia and Gross enrolment ratio (%) of Vanuatu?
Provide a short and direct response. 11.51. In the year 2005, what is the difference between the Gross enrolment ratio (%) in East Asia (all income levels) and Gross enrolment ratio (%) in Argentina?
Your answer should be compact. -1.76. In the year 2005, what is the difference between the Gross enrolment ratio (%) of East Asia (all income levels) and Gross enrolment ratio (%) of Cambodia?
Your answer should be very brief. -22.17. In the year 2005, what is the difference between the Gross enrolment ratio (%) of East Asia (all income levels) and Gross enrolment ratio (%) of Vanuatu?
Offer a very short reply. -6.36. In the year 2005, what is the difference between the Gross enrolment ratio (%) of Argentina and Gross enrolment ratio (%) of Cambodia?
Provide a succinct answer. -20.41. In the year 2005, what is the difference between the Gross enrolment ratio (%) in Argentina and Gross enrolment ratio (%) in Vanuatu?
Keep it short and to the point. -4.6. In the year 2005, what is the difference between the Gross enrolment ratio (%) of Cambodia and Gross enrolment ratio (%) of Vanuatu?
Keep it short and to the point. 15.81. In the year 2006, what is the difference between the Gross enrolment ratio (%) in East Asia (all income levels) and Gross enrolment ratio (%) in Argentina?
Ensure brevity in your answer.  -2.66. In the year 2006, what is the difference between the Gross enrolment ratio (%) of East Asia (all income levels) and Gross enrolment ratio (%) of Cambodia?
Ensure brevity in your answer.  -21.62. In the year 2006, what is the difference between the Gross enrolment ratio (%) in East Asia (all income levels) and Gross enrolment ratio (%) in Vanuatu?
Your answer should be compact. 0.23. In the year 2006, what is the difference between the Gross enrolment ratio (%) of Argentina and Gross enrolment ratio (%) of Cambodia?
Provide a short and direct response. -18.96. In the year 2006, what is the difference between the Gross enrolment ratio (%) in Argentina and Gross enrolment ratio (%) in Vanuatu?
Your answer should be compact. 2.89. In the year 2006, what is the difference between the Gross enrolment ratio (%) of Cambodia and Gross enrolment ratio (%) of Vanuatu?
Offer a terse response. 21.85. In the year 2007, what is the difference between the Gross enrolment ratio (%) of East Asia (all income levels) and Gross enrolment ratio (%) of Argentina?
Provide a short and direct response. -0.85. In the year 2007, what is the difference between the Gross enrolment ratio (%) of East Asia (all income levels) and Gross enrolment ratio (%) of Cambodia?
Provide a short and direct response. -19.71. In the year 2007, what is the difference between the Gross enrolment ratio (%) of East Asia (all income levels) and Gross enrolment ratio (%) of Vanuatu?
Provide a short and direct response. 2.33. In the year 2007, what is the difference between the Gross enrolment ratio (%) in Argentina and Gross enrolment ratio (%) in Cambodia?
Your answer should be compact. -18.86. In the year 2007, what is the difference between the Gross enrolment ratio (%) in Argentina and Gross enrolment ratio (%) in Vanuatu?
Provide a succinct answer. 3.19. In the year 2007, what is the difference between the Gross enrolment ratio (%) in Cambodia and Gross enrolment ratio (%) in Vanuatu?
Make the answer very short. 22.05. What is the ratio of the Gross enrolment ratio (%) of Argentina in 2000 to that in 2001?
Offer a terse response. 1. What is the ratio of the Gross enrolment ratio (%) in Cambodia in 2000 to that in 2001?
Give a very brief answer. 0.92. What is the ratio of the Gross enrolment ratio (%) of Vanuatu in 2000 to that in 2001?
Ensure brevity in your answer.  0.99. What is the ratio of the Gross enrolment ratio (%) in East Asia (all income levels) in 2000 to that in 2002?
Your answer should be very brief. 0.98. What is the ratio of the Gross enrolment ratio (%) of Cambodia in 2000 to that in 2002?
Your answer should be very brief. 0.83. What is the ratio of the Gross enrolment ratio (%) in East Asia (all income levels) in 2000 to that in 2003?
Your answer should be very brief. 0.96. What is the ratio of the Gross enrolment ratio (%) of Argentina in 2000 to that in 2003?
Offer a very short reply. 1.01. What is the ratio of the Gross enrolment ratio (%) in Cambodia in 2000 to that in 2003?
Keep it short and to the point. 0.81. What is the ratio of the Gross enrolment ratio (%) of Vanuatu in 2000 to that in 2003?
Provide a succinct answer. 0.96. What is the ratio of the Gross enrolment ratio (%) of East Asia (all income levels) in 2000 to that in 2004?
Ensure brevity in your answer.  0.95. What is the ratio of the Gross enrolment ratio (%) in Argentina in 2000 to that in 2004?
Provide a succinct answer. 1. What is the ratio of the Gross enrolment ratio (%) in Cambodia in 2000 to that in 2004?
Your answer should be compact. 0.8. What is the ratio of the Gross enrolment ratio (%) of East Asia (all income levels) in 2000 to that in 2005?
Make the answer very short. 0.94. What is the ratio of the Gross enrolment ratio (%) of Cambodia in 2000 to that in 2005?
Your response must be concise. 0.8. What is the ratio of the Gross enrolment ratio (%) in Vanuatu in 2000 to that in 2005?
Offer a very short reply. 1.02. What is the ratio of the Gross enrolment ratio (%) of East Asia (all income levels) in 2000 to that in 2006?
Your answer should be very brief. 0.93. What is the ratio of the Gross enrolment ratio (%) of Argentina in 2000 to that in 2006?
Offer a very short reply. 1. What is the ratio of the Gross enrolment ratio (%) of Cambodia in 2000 to that in 2006?
Offer a terse response. 0.8. What is the ratio of the Gross enrolment ratio (%) of Vanuatu in 2000 to that in 2006?
Your response must be concise. 1.08. What is the ratio of the Gross enrolment ratio (%) of East Asia (all income levels) in 2000 to that in 2007?
Your answer should be very brief. 0.91. What is the ratio of the Gross enrolment ratio (%) in Argentina in 2000 to that in 2007?
Offer a very short reply. 0.99. What is the ratio of the Gross enrolment ratio (%) of Cambodia in 2000 to that in 2007?
Ensure brevity in your answer.  0.79. What is the ratio of the Gross enrolment ratio (%) of Vanuatu in 2000 to that in 2007?
Provide a short and direct response. 1.07. What is the ratio of the Gross enrolment ratio (%) in East Asia (all income levels) in 2001 to that in 2002?
Offer a very short reply. 0.98. What is the ratio of the Gross enrolment ratio (%) in Argentina in 2001 to that in 2002?
Give a very brief answer. 1. What is the ratio of the Gross enrolment ratio (%) in Cambodia in 2001 to that in 2002?
Ensure brevity in your answer.  0.9. What is the ratio of the Gross enrolment ratio (%) in East Asia (all income levels) in 2001 to that in 2003?
Provide a short and direct response. 0.97. What is the ratio of the Gross enrolment ratio (%) of Argentina in 2001 to that in 2003?
Provide a succinct answer. 1.02. What is the ratio of the Gross enrolment ratio (%) of Cambodia in 2001 to that in 2003?
Keep it short and to the point. 0.88. What is the ratio of the Gross enrolment ratio (%) of Vanuatu in 2001 to that in 2003?
Keep it short and to the point. 0.97. What is the ratio of the Gross enrolment ratio (%) of East Asia (all income levels) in 2001 to that in 2004?
Make the answer very short. 0.95. What is the ratio of the Gross enrolment ratio (%) of Argentina in 2001 to that in 2004?
Give a very brief answer. 1.01. What is the ratio of the Gross enrolment ratio (%) of Cambodia in 2001 to that in 2004?
Your response must be concise. 0.87. What is the ratio of the Gross enrolment ratio (%) in Vanuatu in 2001 to that in 2004?
Make the answer very short. 1. What is the ratio of the Gross enrolment ratio (%) in East Asia (all income levels) in 2001 to that in 2005?
Make the answer very short. 0.95. What is the ratio of the Gross enrolment ratio (%) in Argentina in 2001 to that in 2005?
Your answer should be very brief. 1.01. What is the ratio of the Gross enrolment ratio (%) in Cambodia in 2001 to that in 2005?
Ensure brevity in your answer.  0.86. What is the ratio of the Gross enrolment ratio (%) of Vanuatu in 2001 to that in 2005?
Make the answer very short. 1.03. What is the ratio of the Gross enrolment ratio (%) of East Asia (all income levels) in 2001 to that in 2006?
Give a very brief answer. 0.94. What is the ratio of the Gross enrolment ratio (%) of Cambodia in 2001 to that in 2006?
Provide a short and direct response. 0.86. What is the ratio of the Gross enrolment ratio (%) of Vanuatu in 2001 to that in 2006?
Make the answer very short. 1.08. What is the ratio of the Gross enrolment ratio (%) of East Asia (all income levels) in 2001 to that in 2007?
Keep it short and to the point. 0.92. What is the ratio of the Gross enrolment ratio (%) of Cambodia in 2001 to that in 2007?
Offer a very short reply. 0.86. What is the ratio of the Gross enrolment ratio (%) in Vanuatu in 2001 to that in 2007?
Provide a succinct answer. 1.07. What is the ratio of the Gross enrolment ratio (%) of East Asia (all income levels) in 2002 to that in 2003?
Offer a terse response. 0.98. What is the ratio of the Gross enrolment ratio (%) in Cambodia in 2002 to that in 2003?
Give a very brief answer. 0.98. What is the ratio of the Gross enrolment ratio (%) of Vanuatu in 2002 to that in 2003?
Provide a short and direct response. 0.97. What is the ratio of the Gross enrolment ratio (%) of East Asia (all income levels) in 2002 to that in 2004?
Make the answer very short. 0.97. What is the ratio of the Gross enrolment ratio (%) in Argentina in 2002 to that in 2004?
Offer a very short reply. 1.01. What is the ratio of the Gross enrolment ratio (%) of Cambodia in 2002 to that in 2004?
Provide a succinct answer. 0.97. What is the ratio of the Gross enrolment ratio (%) of East Asia (all income levels) in 2002 to that in 2005?
Keep it short and to the point. 0.96. What is the ratio of the Gross enrolment ratio (%) in Argentina in 2002 to that in 2005?
Give a very brief answer. 1.02. What is the ratio of the Gross enrolment ratio (%) in Cambodia in 2002 to that in 2005?
Ensure brevity in your answer.  0.96. What is the ratio of the Gross enrolment ratio (%) of Vanuatu in 2002 to that in 2005?
Keep it short and to the point. 1.03. What is the ratio of the Gross enrolment ratio (%) in East Asia (all income levels) in 2002 to that in 2006?
Provide a short and direct response. 0.96. What is the ratio of the Gross enrolment ratio (%) of Cambodia in 2002 to that in 2006?
Your answer should be compact. 0.96. What is the ratio of the Gross enrolment ratio (%) in Vanuatu in 2002 to that in 2006?
Your answer should be compact. 1.09. What is the ratio of the Gross enrolment ratio (%) in East Asia (all income levels) in 2002 to that in 2007?
Provide a short and direct response. 0.93. What is the ratio of the Gross enrolment ratio (%) in Cambodia in 2002 to that in 2007?
Give a very brief answer. 0.95. What is the ratio of the Gross enrolment ratio (%) in Vanuatu in 2002 to that in 2007?
Your response must be concise. 1.08. What is the ratio of the Gross enrolment ratio (%) of East Asia (all income levels) in 2003 to that in 2004?
Offer a terse response. 0.99. What is the ratio of the Gross enrolment ratio (%) of Vanuatu in 2003 to that in 2004?
Provide a succinct answer. 1.03. What is the ratio of the Gross enrolment ratio (%) of Argentina in 2003 to that in 2005?
Your response must be concise. 1. What is the ratio of the Gross enrolment ratio (%) of Cambodia in 2003 to that in 2005?
Give a very brief answer. 0.98. What is the ratio of the Gross enrolment ratio (%) in Vanuatu in 2003 to that in 2005?
Keep it short and to the point. 1.06. What is the ratio of the Gross enrolment ratio (%) in East Asia (all income levels) in 2003 to that in 2006?
Make the answer very short. 0.97. What is the ratio of the Gross enrolment ratio (%) of Argentina in 2003 to that in 2006?
Give a very brief answer. 0.98. What is the ratio of the Gross enrolment ratio (%) of Cambodia in 2003 to that in 2006?
Your answer should be compact. 0.98. What is the ratio of the Gross enrolment ratio (%) of Vanuatu in 2003 to that in 2006?
Provide a succinct answer. 1.12. What is the ratio of the Gross enrolment ratio (%) in East Asia (all income levels) in 2003 to that in 2007?
Make the answer very short. 0.95. What is the ratio of the Gross enrolment ratio (%) in Argentina in 2003 to that in 2007?
Keep it short and to the point. 0.97. What is the ratio of the Gross enrolment ratio (%) of Cambodia in 2003 to that in 2007?
Your answer should be compact. 0.97. What is the ratio of the Gross enrolment ratio (%) in Vanuatu in 2003 to that in 2007?
Keep it short and to the point. 1.11. What is the ratio of the Gross enrolment ratio (%) in East Asia (all income levels) in 2004 to that in 2005?
Offer a terse response. 0.99. What is the ratio of the Gross enrolment ratio (%) in Argentina in 2004 to that in 2005?
Give a very brief answer. 1. What is the ratio of the Gross enrolment ratio (%) in Vanuatu in 2004 to that in 2005?
Keep it short and to the point. 1.03. What is the ratio of the Gross enrolment ratio (%) in East Asia (all income levels) in 2004 to that in 2006?
Offer a terse response. 0.99. What is the ratio of the Gross enrolment ratio (%) in Argentina in 2004 to that in 2006?
Your answer should be very brief. 0.99. What is the ratio of the Gross enrolment ratio (%) of Cambodia in 2004 to that in 2006?
Provide a succinct answer. 0.99. What is the ratio of the Gross enrolment ratio (%) of Vanuatu in 2004 to that in 2006?
Your answer should be compact. 1.09. What is the ratio of the Gross enrolment ratio (%) of East Asia (all income levels) in 2004 to that in 2007?
Provide a short and direct response. 0.96. What is the ratio of the Gross enrolment ratio (%) in Argentina in 2004 to that in 2007?
Offer a very short reply. 0.98. What is the ratio of the Gross enrolment ratio (%) in Cambodia in 2004 to that in 2007?
Give a very brief answer. 0.99. What is the ratio of the Gross enrolment ratio (%) of Vanuatu in 2004 to that in 2007?
Provide a succinct answer. 1.08. What is the ratio of the Gross enrolment ratio (%) in Argentina in 2005 to that in 2006?
Your answer should be very brief. 0.99. What is the ratio of the Gross enrolment ratio (%) of Vanuatu in 2005 to that in 2006?
Your answer should be very brief. 1.05. What is the ratio of the Gross enrolment ratio (%) of East Asia (all income levels) in 2005 to that in 2007?
Offer a very short reply. 0.97. What is the ratio of the Gross enrolment ratio (%) in Argentina in 2005 to that in 2007?
Provide a short and direct response. 0.98. What is the ratio of the Gross enrolment ratio (%) in Vanuatu in 2005 to that in 2007?
Provide a short and direct response. 1.05. What is the ratio of the Gross enrolment ratio (%) in East Asia (all income levels) in 2006 to that in 2007?
Make the answer very short. 0.97. What is the ratio of the Gross enrolment ratio (%) in Argentina in 2006 to that in 2007?
Your response must be concise. 0.99. What is the difference between the highest and the second highest Gross enrolment ratio (%) of East Asia (all income levels)?
Make the answer very short. 2.93. What is the difference between the highest and the second highest Gross enrolment ratio (%) of Argentina?
Provide a succinct answer. 0.84. What is the difference between the highest and the second highest Gross enrolment ratio (%) in Cambodia?
Offer a very short reply. 1.01. What is the difference between the highest and the second highest Gross enrolment ratio (%) of Vanuatu?
Keep it short and to the point. 3.46. What is the difference between the highest and the lowest Gross enrolment ratio (%) of East Asia (all income levels)?
Provide a short and direct response. 10.26. What is the difference between the highest and the lowest Gross enrolment ratio (%) in Argentina?
Make the answer very short. 3.1. What is the difference between the highest and the lowest Gross enrolment ratio (%) of Cambodia?
Your answer should be compact. 28.19. What is the difference between the highest and the lowest Gross enrolment ratio (%) in Vanuatu?
Provide a succinct answer. 13.48. 